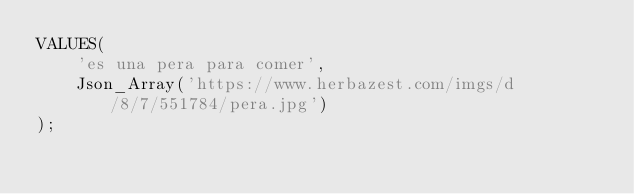Convert code to text. <code><loc_0><loc_0><loc_500><loc_500><_SQL_>VALUES(
    'es una pera para comer',
    Json_Array('https://www.herbazest.com/imgs/d/8/7/551784/pera.jpg')
);</code> 